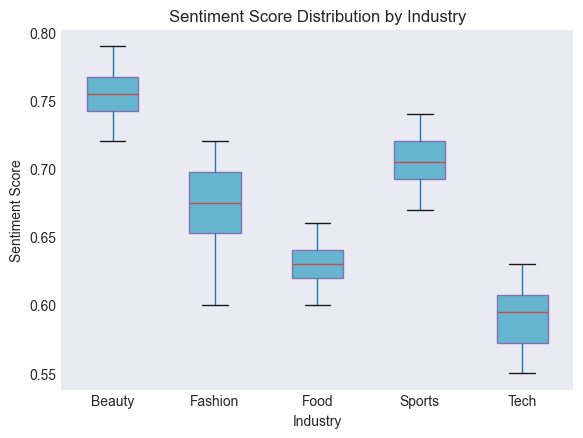Which industry has the highest median sentiment score? To determine this, look at the median lines (usually depicted in red) within the boxes for each industry. The industry with the highest median line is the one with the highest median sentiment score.
Answer: Beauty What's the median sentiment score for the Fashion industry? Locate the median line within the box for the Fashion industry. It's the red line inside the box plot for the Fashion industry.
Answer: 0.68 Which industry shows the most variability in sentiment scores? Variability is depicted by the height of the box. The taller the box, the greater the range (interquartile range). Compare the heights of the boxes to identify the most variable industry.
Answer: Sports Are the median sentiment scores for Tech and Food the same? Compare the median lines within the boxes for Tech and Food industries. If the red lines are at the same vertical position, they have the same median score.
Answer: No Which industry has the smallest interquartile range (IQR) for sentiment scores? The interquartile range is depicted by the height of the box itself. Identify the industry with the shortest box to find the smallest IQR.
Answer: Food Which industry has the lowest minimum sentiment score? The minimum value is represented by the lower whisker or the lowest point in the box plot. Identify the industry with the bottommost whisker or point.
Answer: Tech How do the sentiment score ranges (minimum to maximum) for Fashion and Sports compare? Look at the lengths of the whiskers (the lines extending from the box) and the box itself for both Fashion and Sports. Assess which has a longer range (whisker to whisker) by comparison.
Answer: Sports has a larger range than Fashion What is the interquartile range (IQR) for Beauty's sentiment scores? The interquartile range (IQR) is calculated as the difference between the third quartile (top of the box) and the first quartile (bottom of the box). Estimate these values and subtract the lower quartile from the upper quartile.
Answer: ~0.05 Between which industries is the difference in median sentiment scores the greatest? Compare the medians (red lines) across all industries and identify the pairs with the maximum difference between these medians.
Answer: Beauty and Tech Is there any industry with outliers in sentiment scores? Outliers are typically shown as individual points outside the whiskers (lines extending from the box). Look for any point that lies outside the whiskers in any of the box plots.
Answer: No 